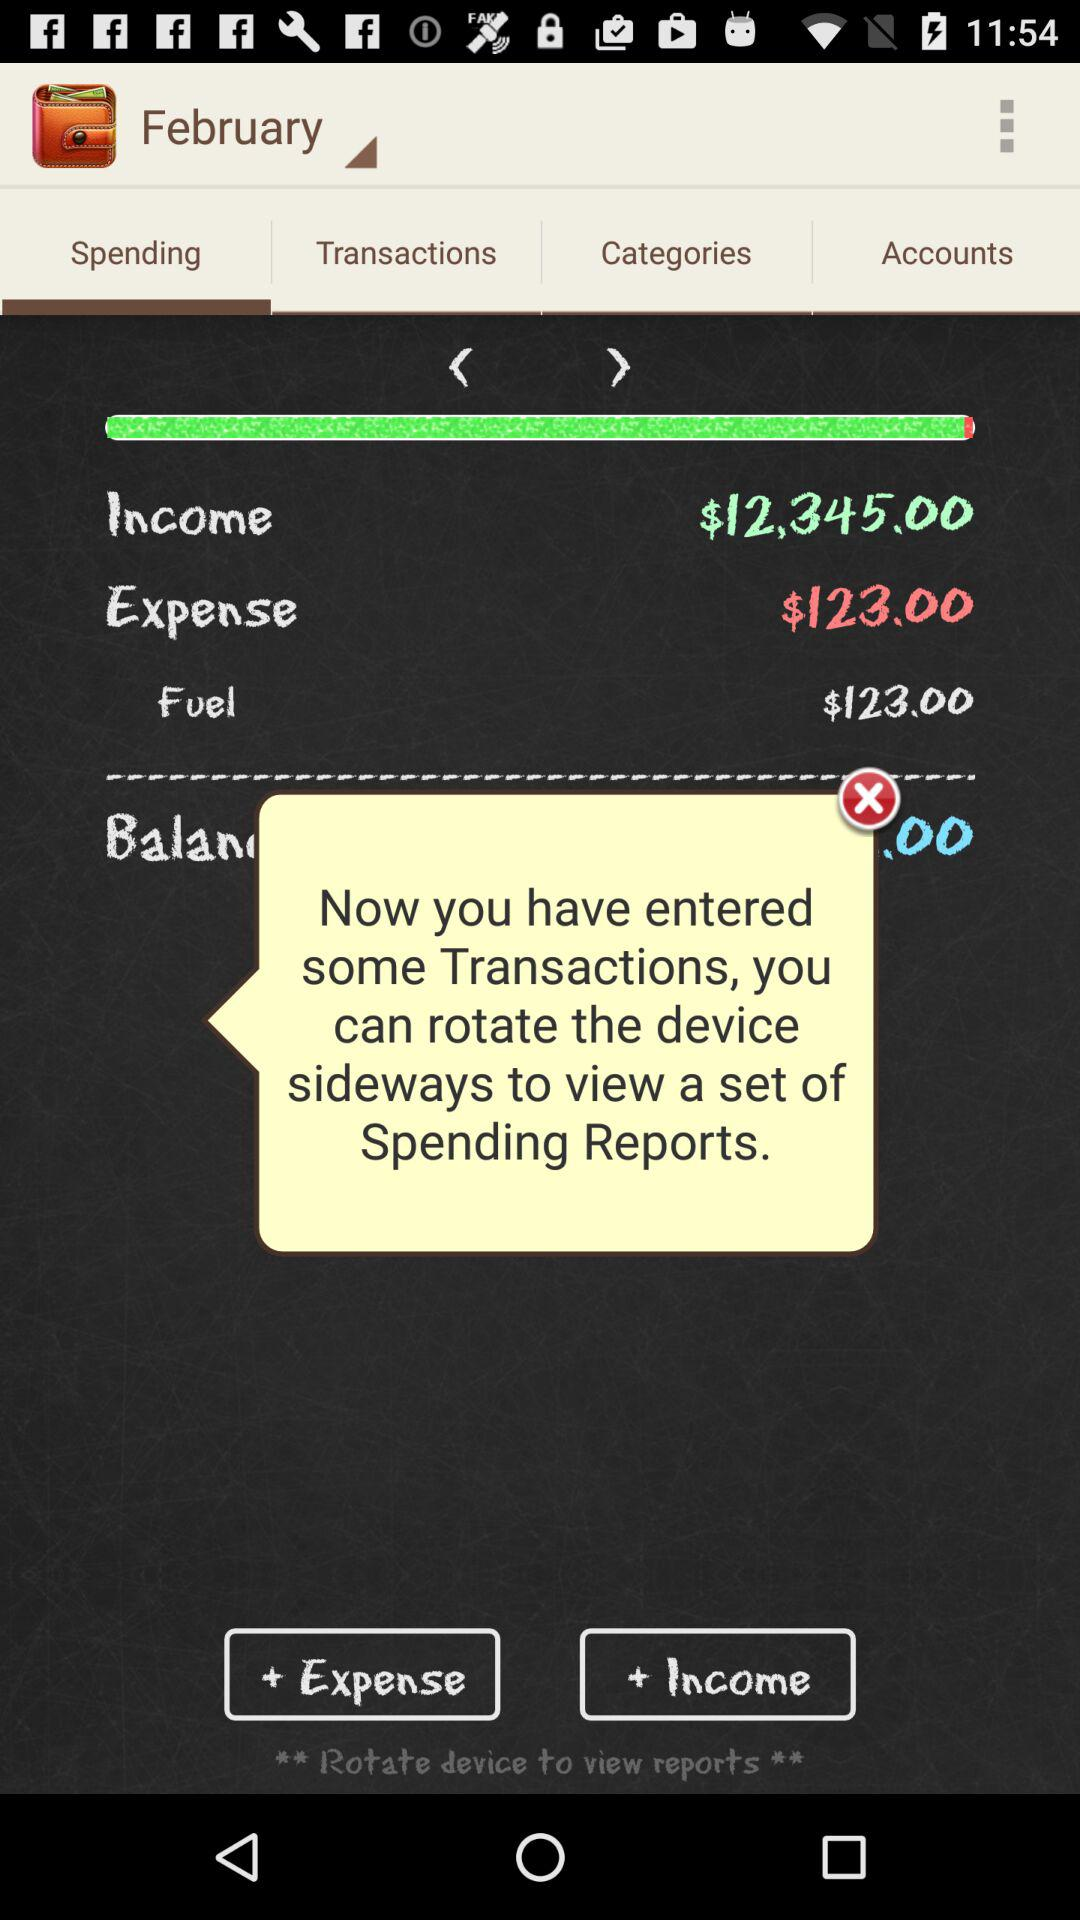Which tab is selected? The selected tab is "Spending". 